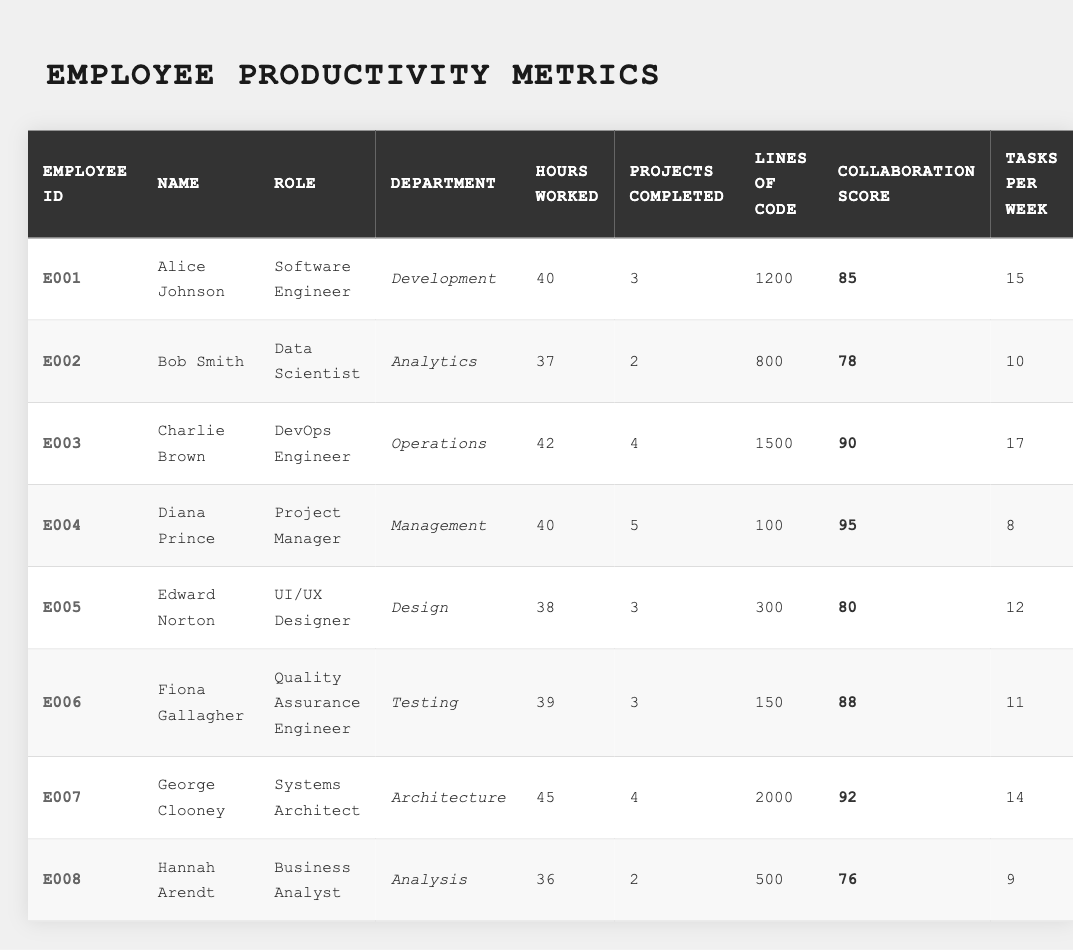What is the total number of projects completed by all employees? To find the total, we sum up the 'Projects Completed' for each employee: 3 + 2 + 4 + 5 + 3 + 3 + 4 + 2 = 26.
Answer: 26 Who has the highest collaboration score? By examining the 'Collaboration Score' column, we can see that Diana Prince has the highest score of 95.
Answer: Diana Prince What is the average number of tasks completed per week across all employees? To find the average, we sum the 'Tasks per Week' of all employees (15 + 10 + 17 + 8 + 12 + 11 + 14 + 9) = 96 and divide by the total number of employees (8): 96/8 = 12.
Answer: 12 Is there an employee who completed more than 4 projects? By checking the 'Projects Completed' column, we notice that both Diana Prince and Charlie Brown completed more than 4 projects.
Answer: Yes Which department does Edward Norton work in, and what is his role? Edward Norton is in the 'Design' department and his role is 'UI/UX Designer', as seen on his corresponding row.
Answer: Design, UI/UX Designer How many lines of code did George Clooney write? The 'Lines of Code' for George Clooney is specifically noted in the table as 2000.
Answer: 2000 What is the difference in hours worked between the employee with the most hours worked and the one with the least? George Clooney worked 45 hours, while Hannah Arendt worked 36 hours. The difference is 45 - 36 = 9 hours.
Answer: 9 hours Which employee has the lowest number of completed projects? By looking at the 'Projects Completed' column, Bob Smith and Hannah Arendt both have the lowest, with 2 completed projects each.
Answer: Bob Smith and Hannah Arendt Calculate the average collaboration score. To find the average collaboration score, we sum all scores (85 + 78 + 90 + 95 + 80 + 88 + 92 + 76) = 704 and divide by 8: 704/8 = 88.
Answer: 88 What role does Alice Johnson have, and how many lines of code did she write? Alice Johnson's role is 'Software Engineer', and she wrote 1200 lines of code according to the table.
Answer: Software Engineer, 1200 lines of code How many employees worked fewer than 40 hours? By reviewing the 'Hours Worked' column, we find that Bob Smith (37), Hannah Arendt (36), and Edward Norton (38) worked fewer than 40 hours, totaling 3 employees.
Answer: 3 employees 